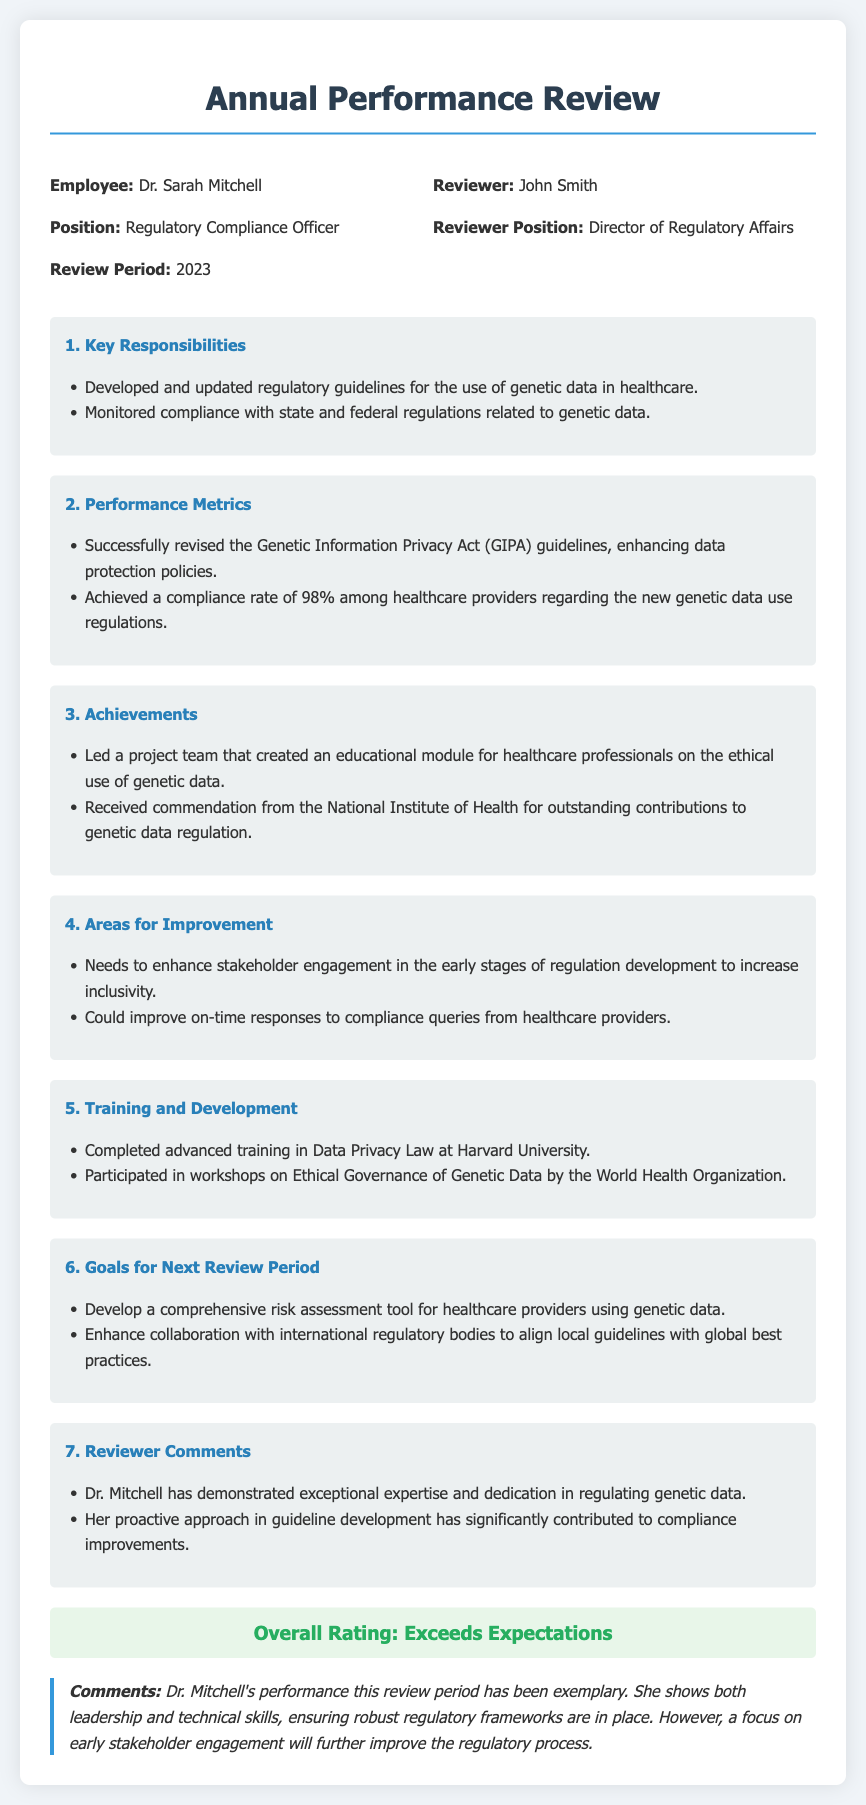What is the employee's name? The employee's name is stated at the top of the document, specifically under the Employee section.
Answer: Dr. Sarah Mitchell What position does the employee hold? The employee's position is mentioned directly under their name.
Answer: Regulatory Compliance Officer What was the compliance rate achieved among healthcare providers? The compliance rate is listed under Performance Metrics in the document.
Answer: 98% Who reviewed Dr. Sarah Mitchell? The reviewer is identified in the header information section.
Answer: John Smith What guideline was successfully revised by Dr. Mitchell? The revised guideline is specified in the Performance Metrics section.
Answer: Genetic Information Privacy Act (GIPA) What training did Dr. Mitchell complete at Harvard University? The completed training is detailed in the Training and Development section.
Answer: Data Privacy Law What is one area for improvement for Dr. Mitchell? The areas for improvement are listed in a separate section in the document.
Answer: Enhance stakeholder engagement How would the review be rated overall? The overall rating is provided in a specific section near the end of the document.
Answer: Exceeds Expectations What commendation did Dr. Mitchell receive? The commendation is mentioned under Achievements in the document.
Answer: Commendation from the National Institute of Health 